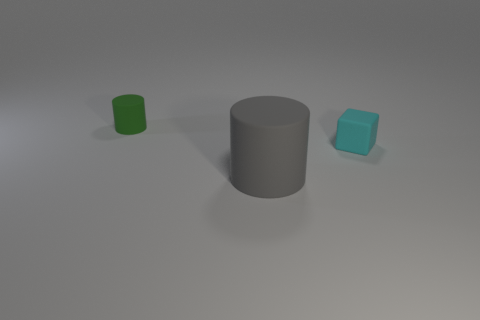Add 1 big brown spheres. How many objects exist? 4 Subtract all cylinders. How many objects are left? 1 Add 2 tiny green matte things. How many tiny green matte things are left? 3 Add 1 big gray rubber things. How many big gray rubber things exist? 2 Subtract 0 purple spheres. How many objects are left? 3 Subtract 1 cylinders. How many cylinders are left? 1 Subtract all yellow cylinders. Subtract all green cubes. How many cylinders are left? 2 Subtract all red cubes. How many gray cylinders are left? 1 Subtract all small purple blocks. Subtract all gray matte cylinders. How many objects are left? 2 